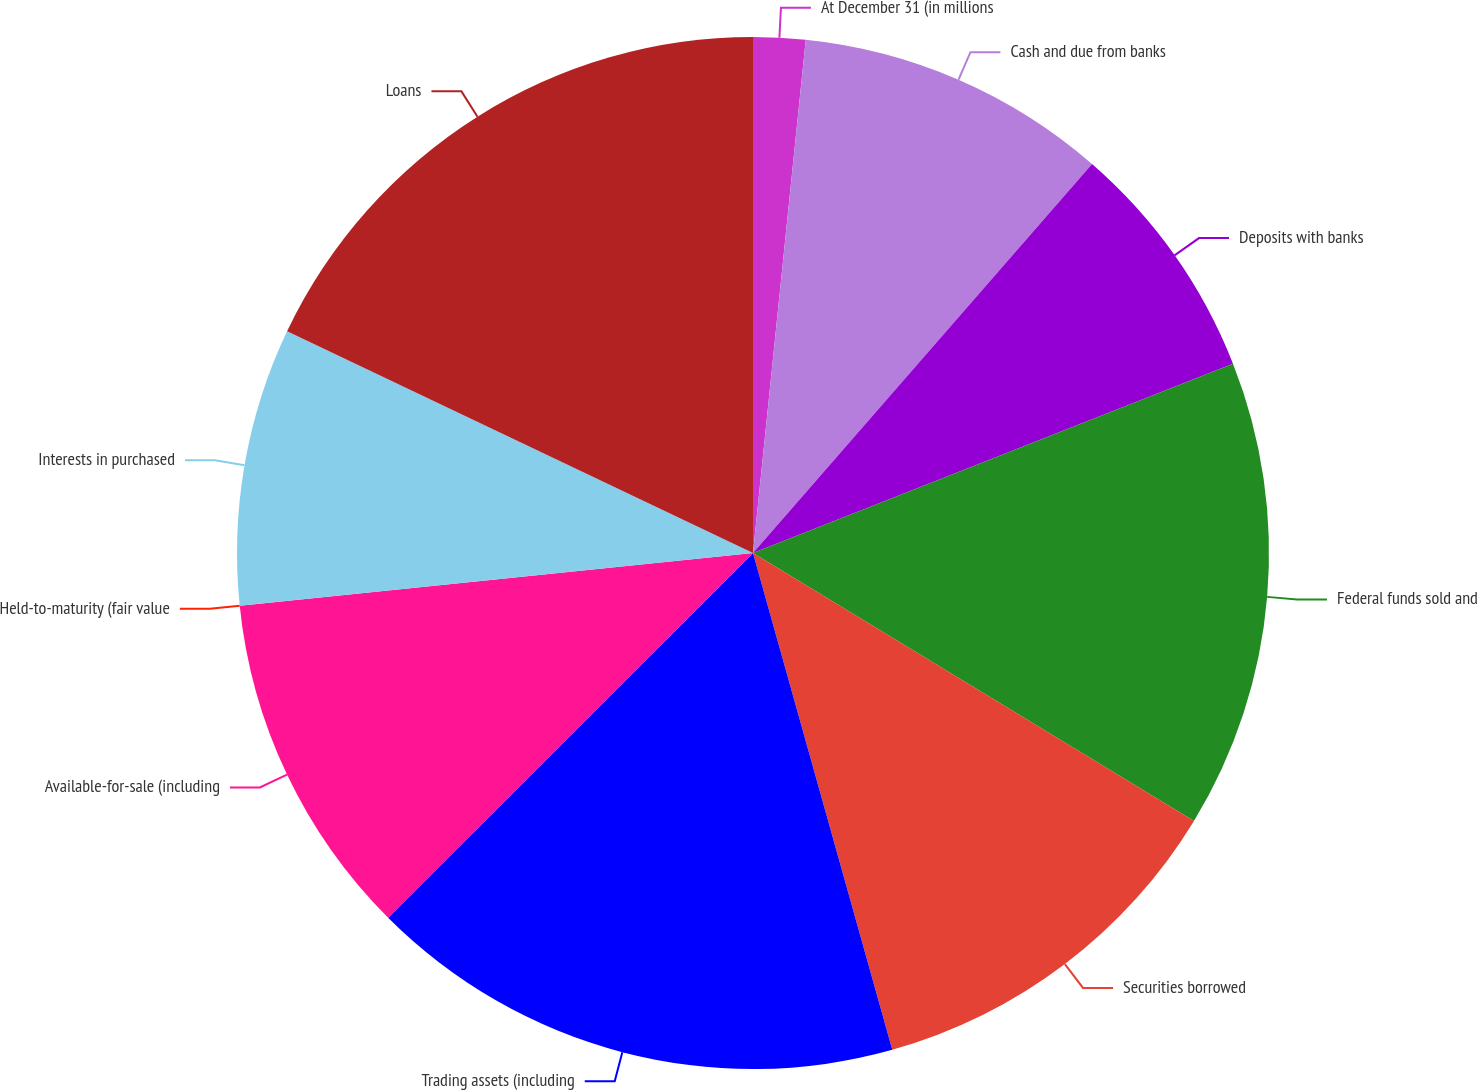Convert chart. <chart><loc_0><loc_0><loc_500><loc_500><pie_chart><fcel>At December 31 (in millions<fcel>Cash and due from banks<fcel>Deposits with banks<fcel>Federal funds sold and<fcel>Securities borrowed<fcel>Trading assets (including<fcel>Available-for-sale (including<fcel>Held-to-maturity (fair value<fcel>Interests in purchased<fcel>Loans<nl><fcel>1.63%<fcel>9.78%<fcel>7.61%<fcel>14.67%<fcel>11.96%<fcel>16.85%<fcel>10.87%<fcel>0.0%<fcel>8.7%<fcel>17.93%<nl></chart> 